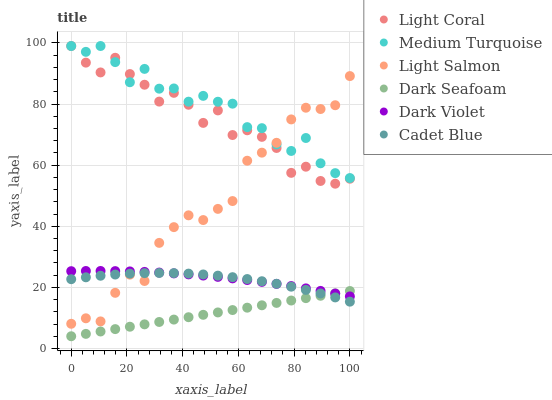Does Dark Seafoam have the minimum area under the curve?
Answer yes or no. Yes. Does Medium Turquoise have the maximum area under the curve?
Answer yes or no. Yes. Does Cadet Blue have the minimum area under the curve?
Answer yes or no. No. Does Cadet Blue have the maximum area under the curve?
Answer yes or no. No. Is Dark Seafoam the smoothest?
Answer yes or no. Yes. Is Light Coral the roughest?
Answer yes or no. Yes. Is Cadet Blue the smoothest?
Answer yes or no. No. Is Cadet Blue the roughest?
Answer yes or no. No. Does Dark Seafoam have the lowest value?
Answer yes or no. Yes. Does Cadet Blue have the lowest value?
Answer yes or no. No. Does Medium Turquoise have the highest value?
Answer yes or no. Yes. Does Cadet Blue have the highest value?
Answer yes or no. No. Is Dark Seafoam less than Light Coral?
Answer yes or no. Yes. Is Light Salmon greater than Dark Seafoam?
Answer yes or no. Yes. Does Light Salmon intersect Medium Turquoise?
Answer yes or no. Yes. Is Light Salmon less than Medium Turquoise?
Answer yes or no. No. Is Light Salmon greater than Medium Turquoise?
Answer yes or no. No. Does Dark Seafoam intersect Light Coral?
Answer yes or no. No. 